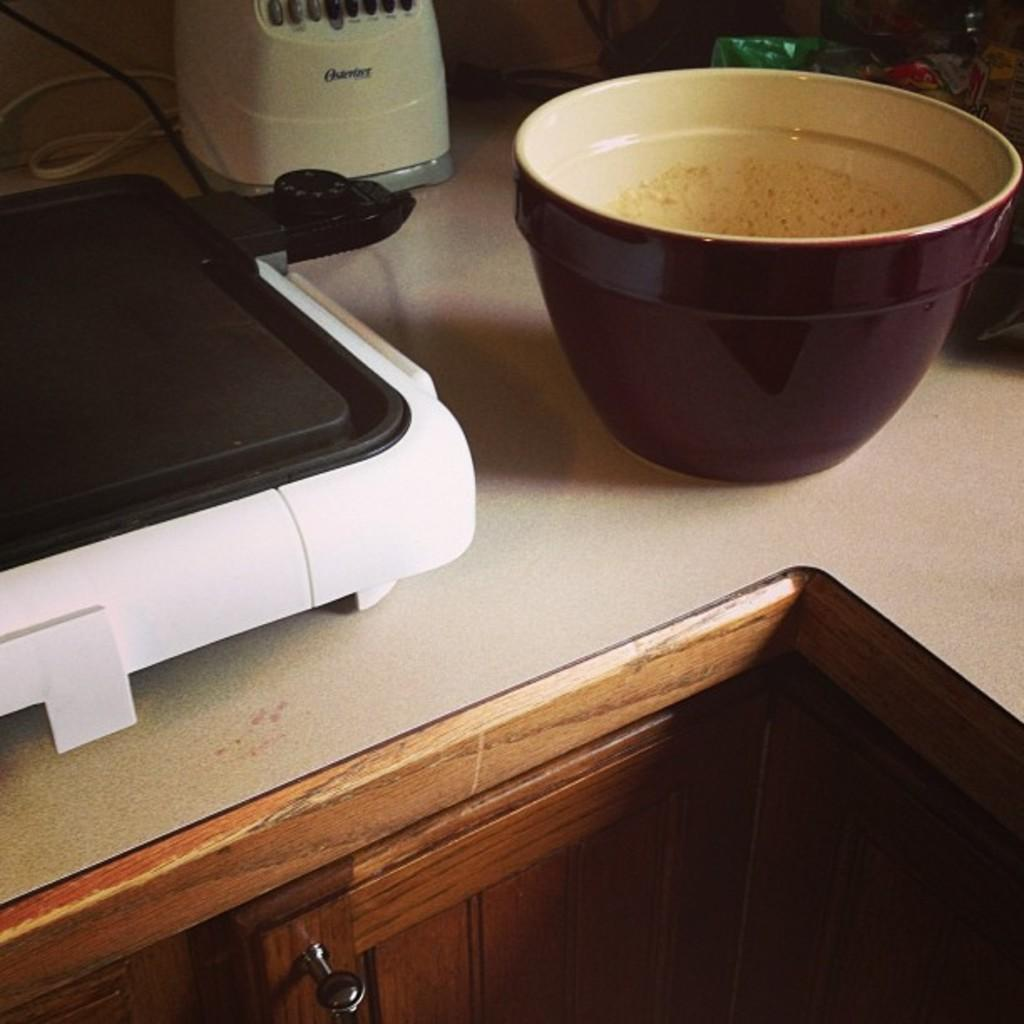Provide a one-sentence caption for the provided image. An Oster brand blender is on a counter with other items. 